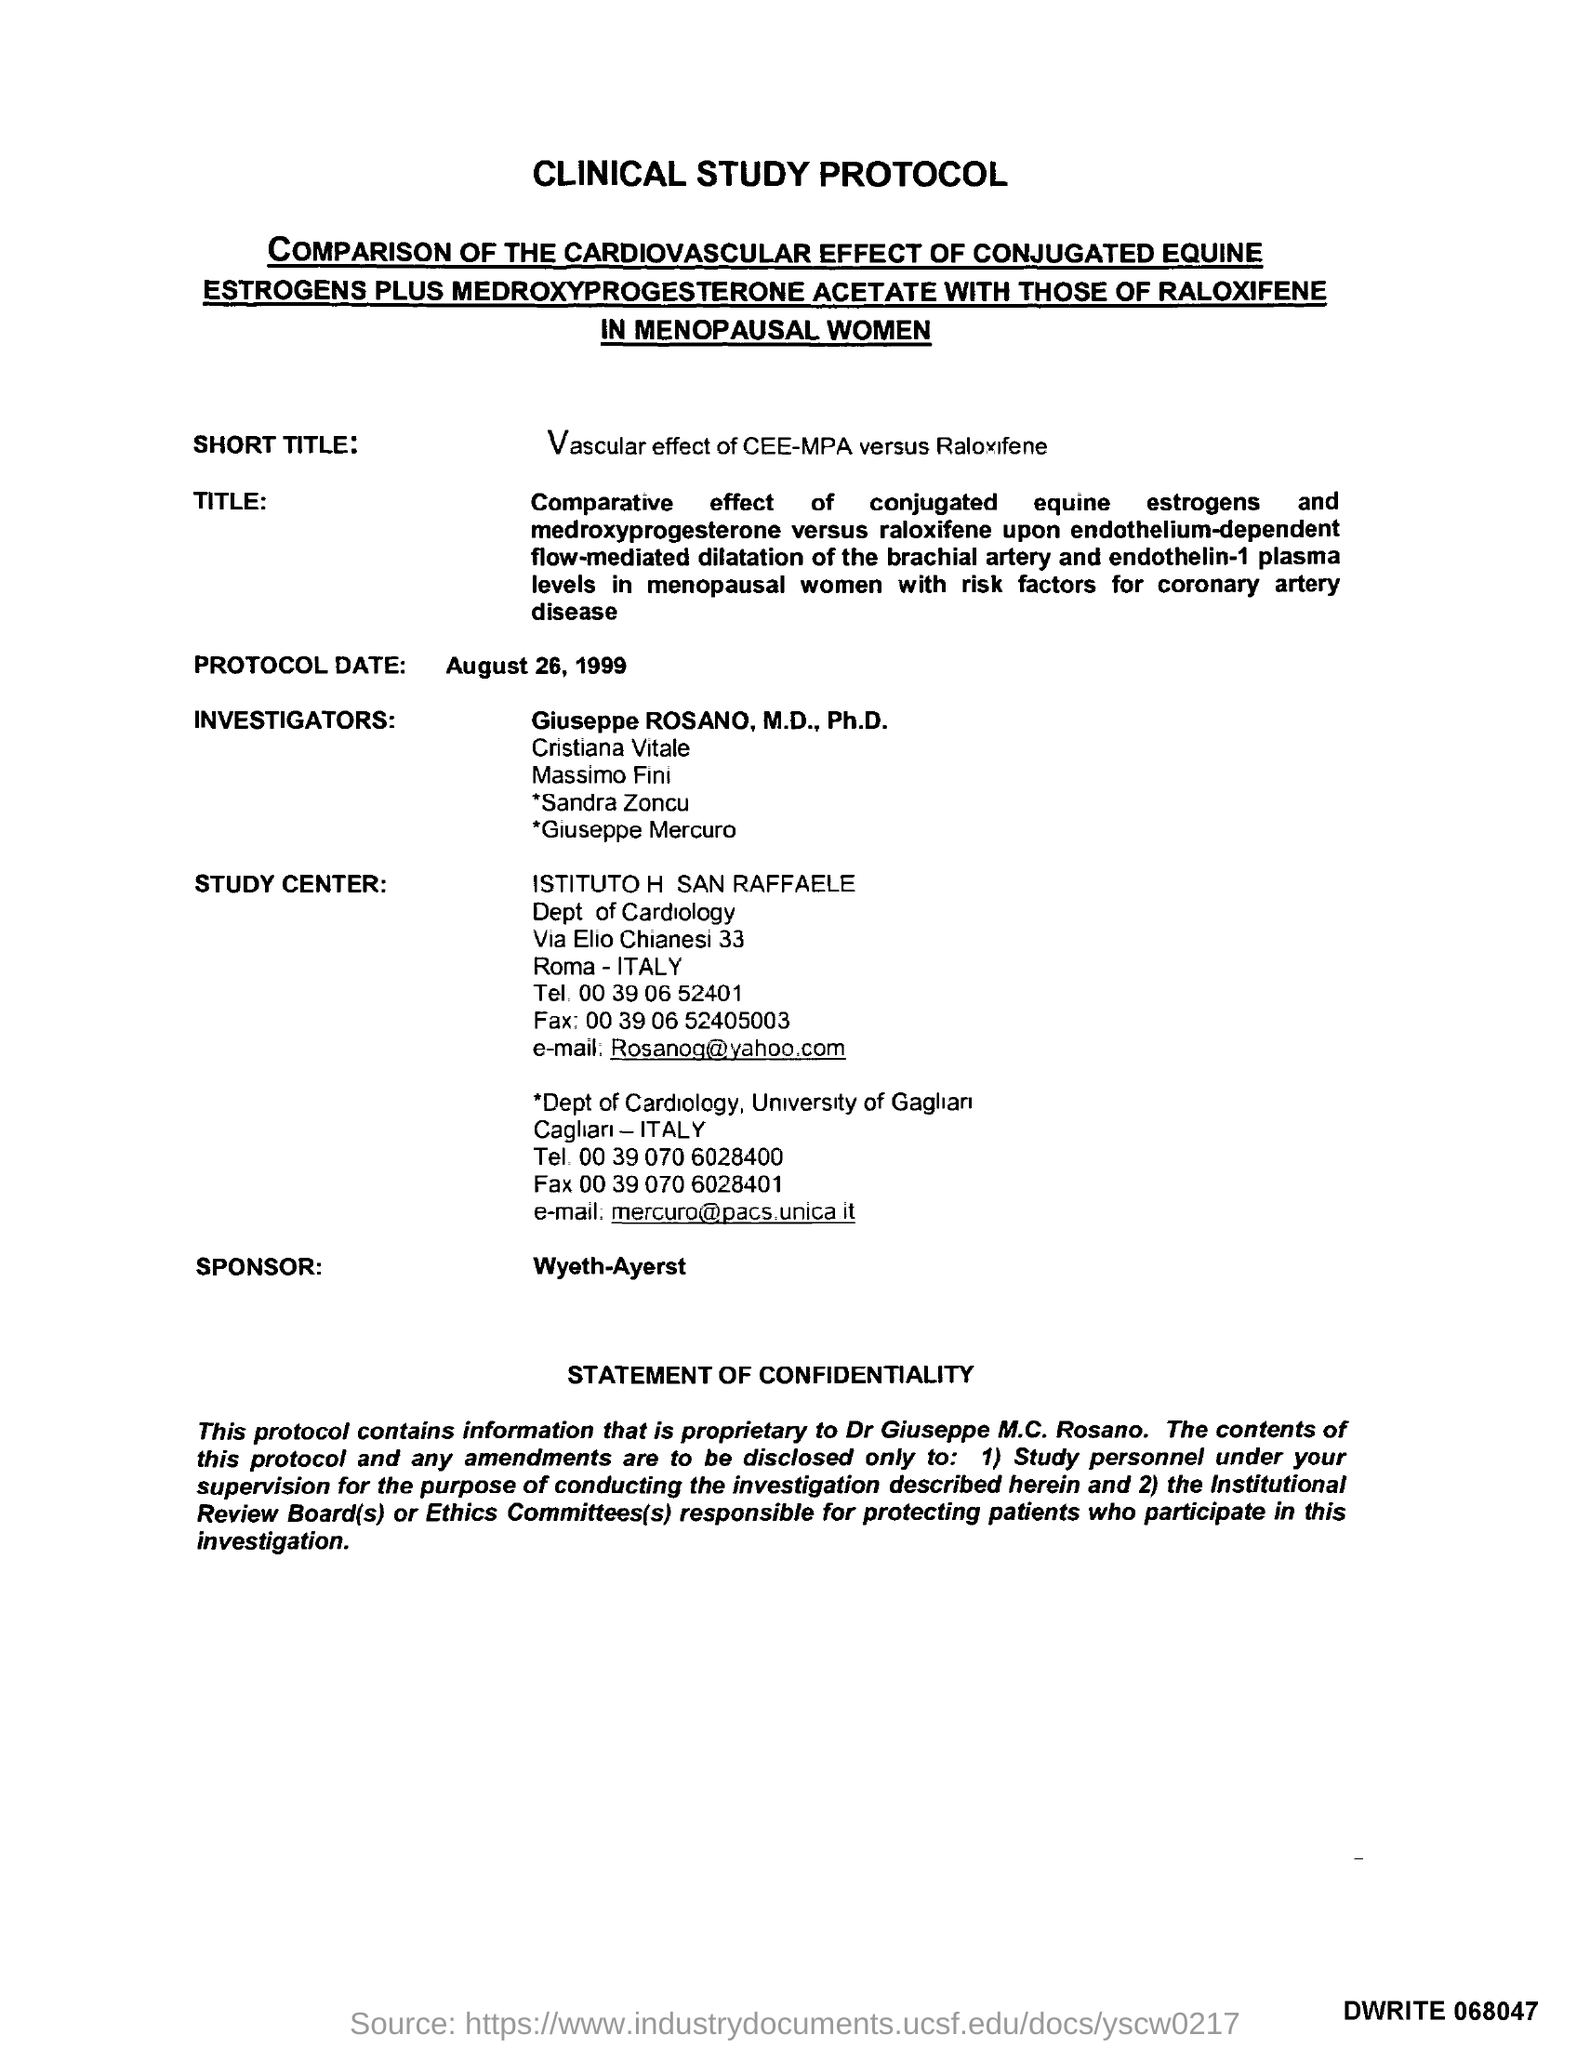What is the Title of the document?
Make the answer very short. Clinical Study Protocol. What is the Protocol Date?
Your answer should be compact. August 26, 1999. Who is the sponsor?
Give a very brief answer. Wyeth-Ayerst. What is the email for ISTITUTO H SAN RAFFAELE?
Provide a short and direct response. Rosanog@yahoo.com. What is the email for Dept of Cradiology, University of Gaglian?
Provide a succinct answer. Mercuro@pacs.unica.it. 